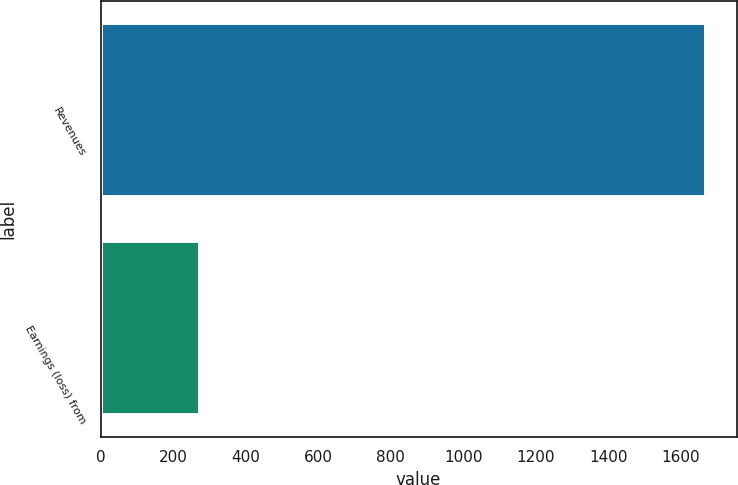<chart> <loc_0><loc_0><loc_500><loc_500><bar_chart><fcel>Revenues<fcel>Earnings (loss) from<nl><fcel>1669.6<fcel>272.8<nl></chart> 